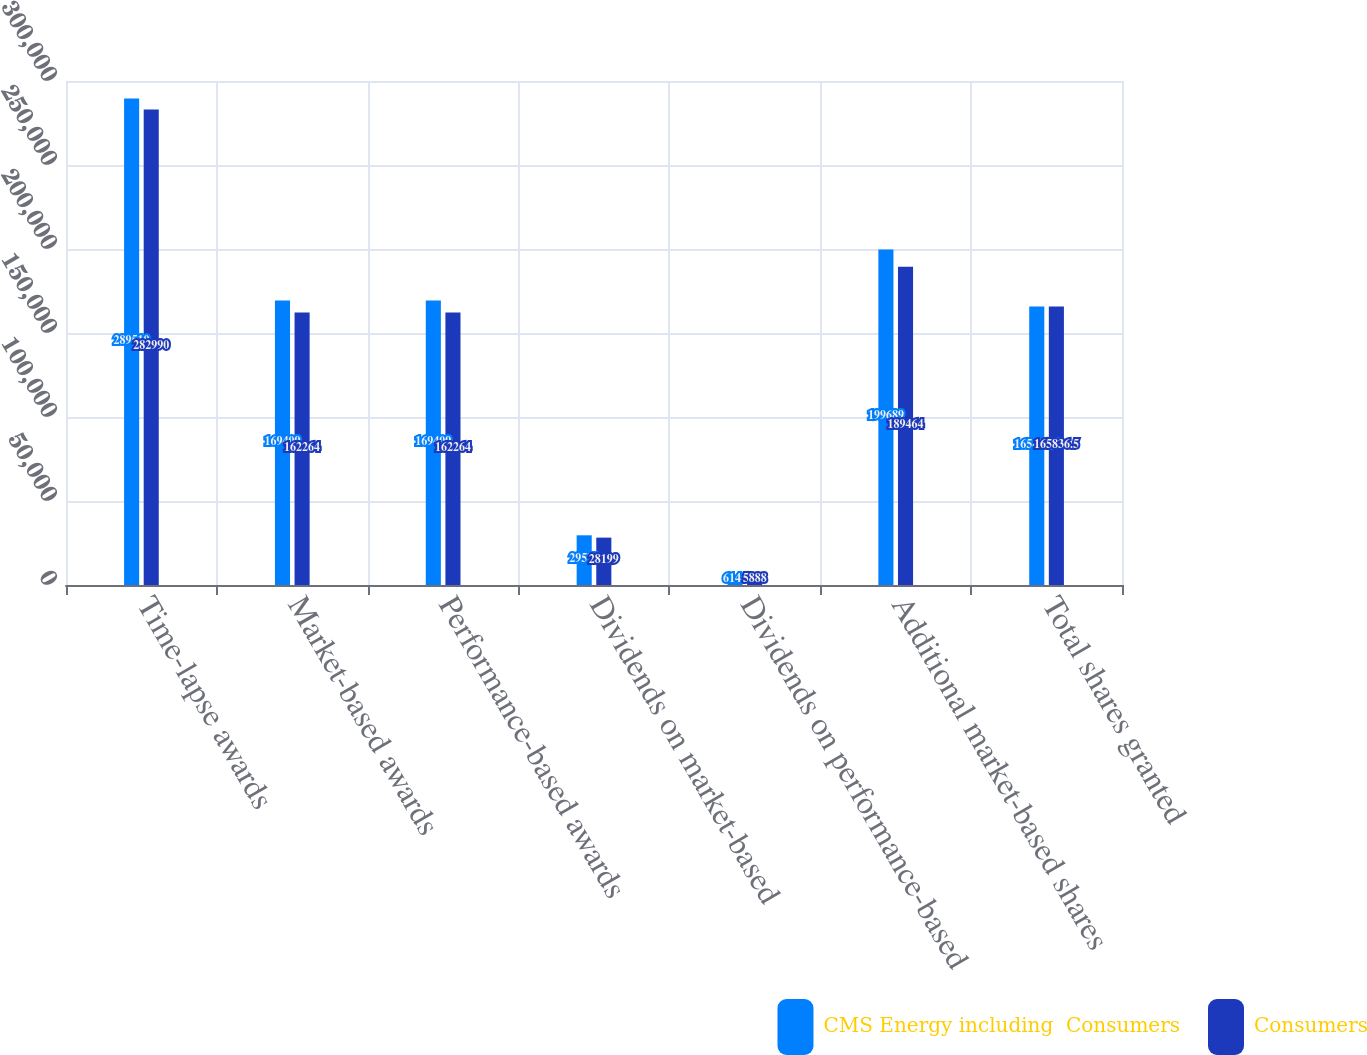Convert chart to OTSL. <chart><loc_0><loc_0><loc_500><loc_500><stacked_bar_chart><ecel><fcel>Time-lapse awards<fcel>Market-based awards<fcel>Performance-based awards<fcel>Dividends on market-based<fcel>Dividends on performance-based<fcel>Additional market-based shares<fcel>Total shares granted<nl><fcel>CMS Energy including  Consumers<fcel>289510<fcel>169409<fcel>169409<fcel>29579<fcel>6146<fcel>199689<fcel>165836<nl><fcel>Consumers<fcel>282990<fcel>162264<fcel>162264<fcel>28199<fcel>5888<fcel>189464<fcel>165836<nl></chart> 